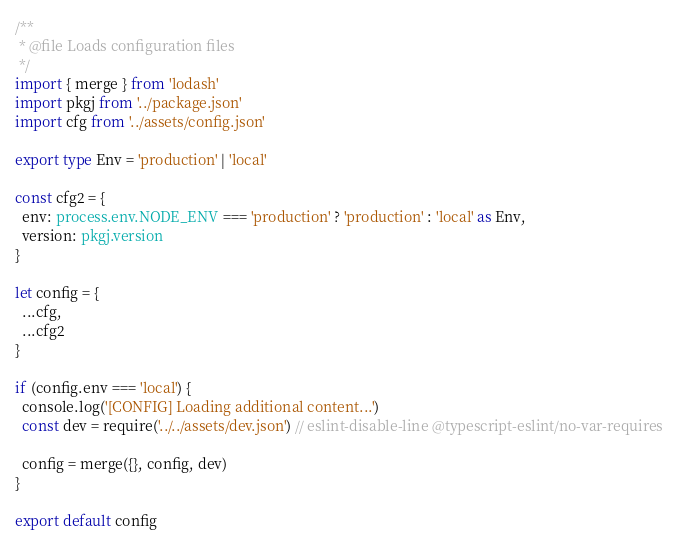Convert code to text. <code><loc_0><loc_0><loc_500><loc_500><_TypeScript_>/**
 * @file Loads configuration files
 */
import { merge } from 'lodash'
import pkgj from '../package.json'
import cfg from '../assets/config.json'

export type Env = 'production' | 'local'

const cfg2 = {
  env: process.env.NODE_ENV === 'production' ? 'production' : 'local' as Env,
  version: pkgj.version
}

let config = {
  ...cfg,
  ...cfg2
}

if (config.env === 'local') {
  console.log('[CONFIG] Loading additional content...')
  const dev = require('../../assets/dev.json') // eslint-disable-line @typescript-eslint/no-var-requires

  config = merge({}, config, dev)
}

export default config
</code> 